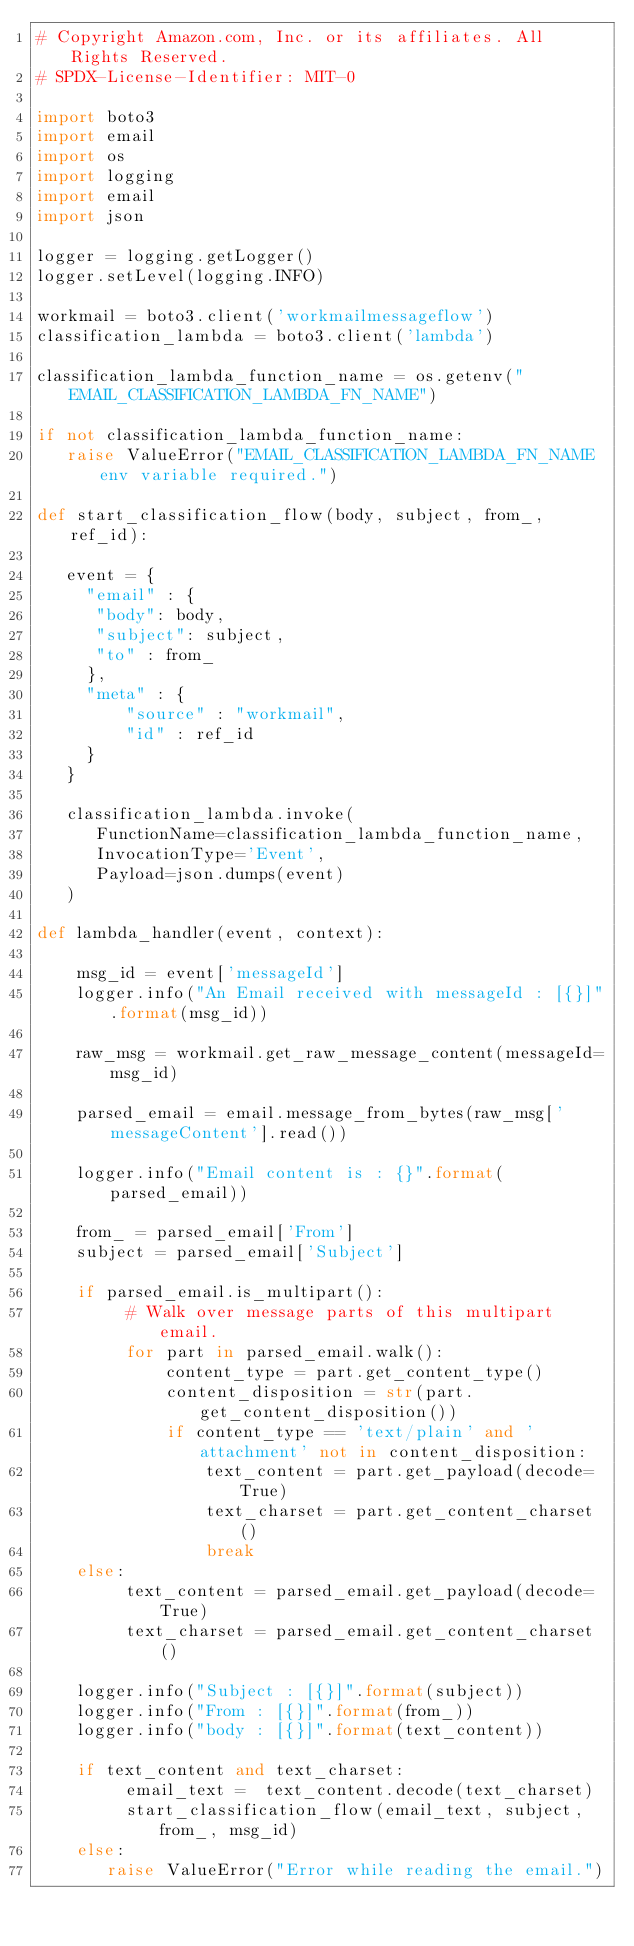<code> <loc_0><loc_0><loc_500><loc_500><_Python_># Copyright Amazon.com, Inc. or its affiliates. All Rights Reserved.
# SPDX-License-Identifier: MIT-0

import boto3
import email
import os
import logging
import email
import json

logger = logging.getLogger()
logger.setLevel(logging.INFO)

workmail = boto3.client('workmailmessageflow')
classification_lambda = boto3.client('lambda')

classification_lambda_function_name = os.getenv("EMAIL_CLASSIFICATION_LAMBDA_FN_NAME")

if not classification_lambda_function_name:
   raise ValueError("EMAIL_CLASSIFICATION_LAMBDA_FN_NAME env variable required.")
   
def start_classification_flow(body, subject, from_, ref_id):
   
   event = {
     "email" : {
      "body": body,   
      "subject": subject,
      "to" : from_
     },
     "meta" : {
         "source" : "workmail",
         "id" : ref_id
     }
   }
   
   classification_lambda.invoke(
      FunctionName=classification_lambda_function_name,
      InvocationType='Event',
      Payload=json.dumps(event)
   )

def lambda_handler(event, context):
    
    msg_id = event['messageId']
    logger.info("An Email received with messageId : [{}]".format(msg_id))
    
    raw_msg = workmail.get_raw_message_content(messageId=msg_id)

    parsed_email = email.message_from_bytes(raw_msg['messageContent'].read())
    
    logger.info("Email content is : {}".format(parsed_email))
    
    from_ = parsed_email['From']
    subject = parsed_email['Subject']

    if parsed_email.is_multipart():
         # Walk over message parts of this multipart email.
         for part in parsed_email.walk():
             content_type = part.get_content_type()
             content_disposition = str(part.get_content_disposition())
             if content_type == 'text/plain' and 'attachment' not in content_disposition:
                 text_content = part.get_payload(decode=True)
                 text_charset = part.get_content_charset()
                 break
    else:
         text_content = parsed_email.get_payload(decode=True)
         text_charset = parsed_email.get_content_charset()

    logger.info("Subject : [{}]".format(subject))
    logger.info("From : [{}]".format(from_))
    logger.info("body : [{}]".format(text_content)) 

    if text_content and text_charset:
         email_text =  text_content.decode(text_charset)
         start_classification_flow(email_text, subject, from_, msg_id)
    else:
       raise ValueError("Error while reading the email.")
       </code> 